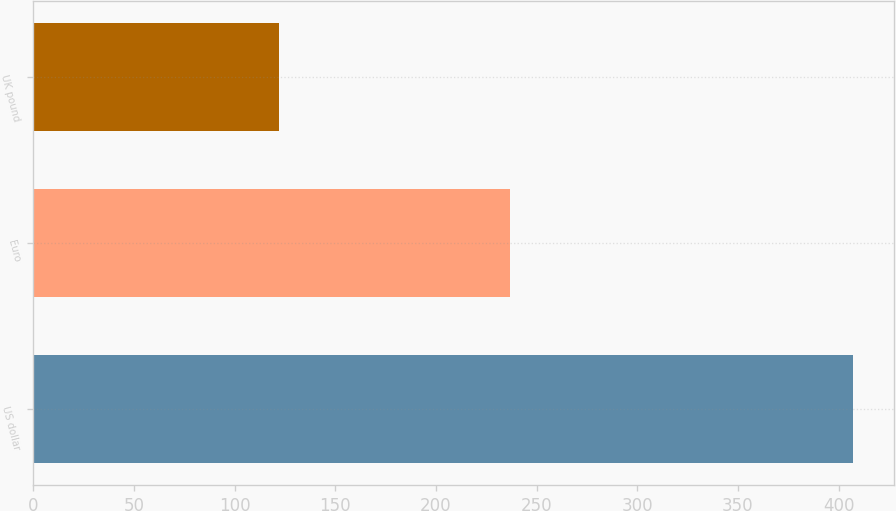Convert chart to OTSL. <chart><loc_0><loc_0><loc_500><loc_500><bar_chart><fcel>US dollar<fcel>Euro<fcel>UK pound<nl><fcel>407<fcel>237<fcel>122<nl></chart> 